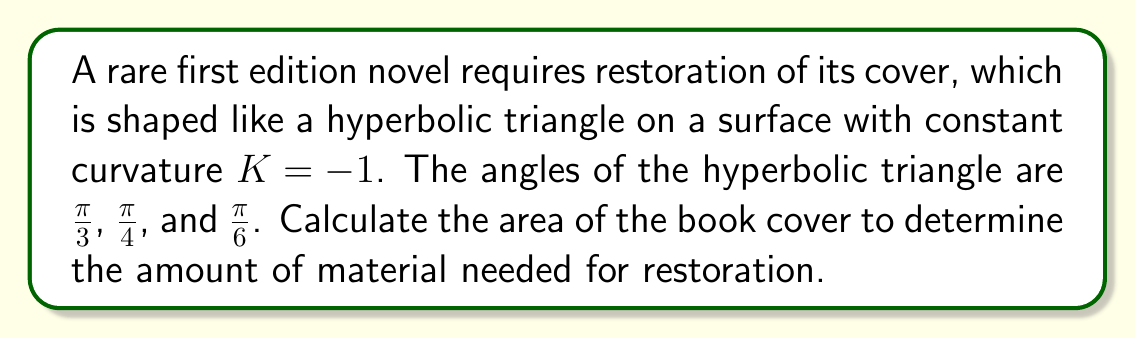Can you answer this question? To solve this problem, we'll use the Gauss-Bonnet formula for hyperbolic triangles:

1) The Gauss-Bonnet formula for a hyperbolic triangle states:
   $$A = \pi - (\alpha + \beta + \gamma)$$
   where $A$ is the area and $\alpha$, $\beta$, and $\gamma$ are the angles of the triangle.

2) We're given the angles:
   $\alpha = \frac{\pi}{3}$, $\beta = \frac{\pi}{4}$, $\gamma = \frac{\pi}{6}$

3) Substituting these into the formula:
   $$A = \pi - (\frac{\pi}{3} + \frac{\pi}{4} + \frac{\pi}{6})$$

4) Simplify:
   $$A = \pi - (\frac{4\pi}{12} + \frac{3\pi}{12} + \frac{2\pi}{12})$$
   $$A = \pi - \frac{9\pi}{12}$$

5) Combine like terms:
   $$A = \frac{12\pi}{12} - \frac{9\pi}{12} = \frac{3\pi}{12} = \frac{\pi}{4}$$

6) Therefore, the area of the hyperbolic triangle is $\frac{\pi}{4}$ square units.

Note: In hyperbolic geometry with $K = -1$, this area is dimensionless. To convert to physical units, you would need to know the scale factor of your hyperbolic plane model.
Answer: $\frac{\pi}{4}$ square units 